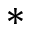<formula> <loc_0><loc_0><loc_500><loc_500>*</formula> 